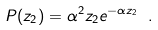Convert formula to latex. <formula><loc_0><loc_0><loc_500><loc_500>P ( z _ { 2 } ) = \alpha ^ { 2 } z _ { 2 } e ^ { - \alpha z _ { 2 } } \ .</formula> 